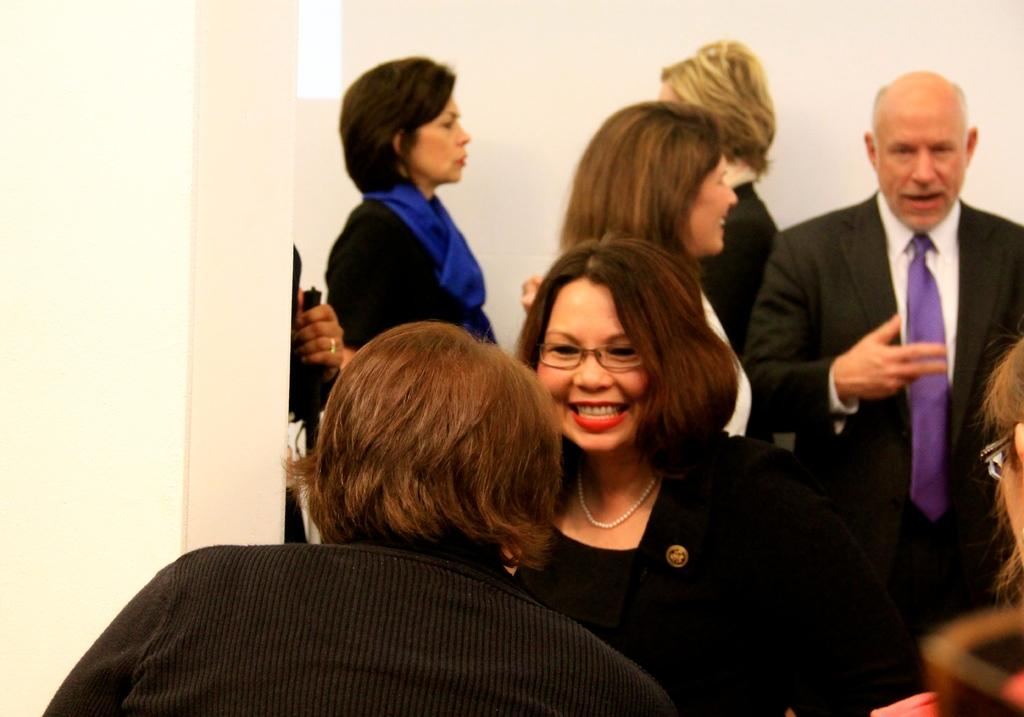Who or what can be seen in the image? There are people in the image. What is visible in the background of the image? There is a wall in the background of the image. What type of degree is the person in the image pursuing? There is no information about a degree in the image, as it only shows people and a wall in the background. 